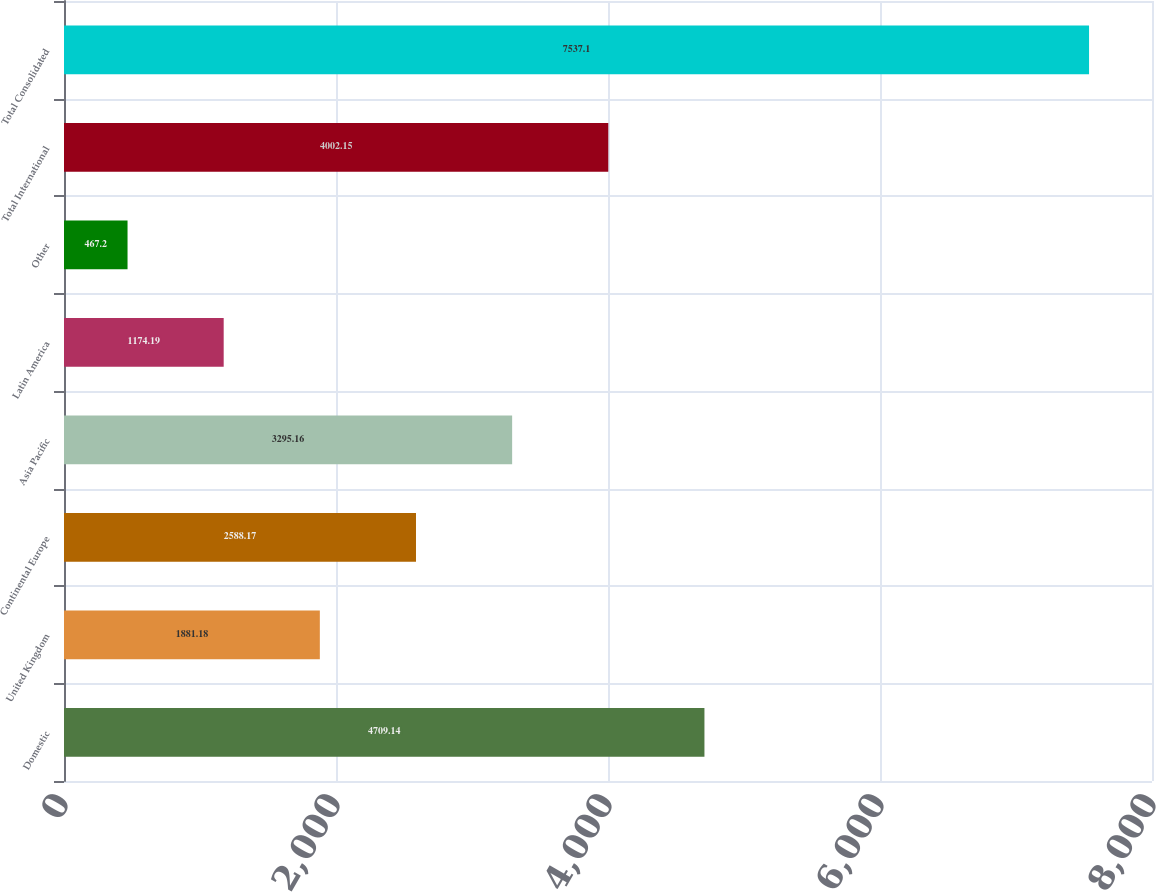Convert chart to OTSL. <chart><loc_0><loc_0><loc_500><loc_500><bar_chart><fcel>Domestic<fcel>United Kingdom<fcel>Continental Europe<fcel>Asia Pacific<fcel>Latin America<fcel>Other<fcel>Total International<fcel>Total Consolidated<nl><fcel>4709.14<fcel>1881.18<fcel>2588.17<fcel>3295.16<fcel>1174.19<fcel>467.2<fcel>4002.15<fcel>7537.1<nl></chart> 